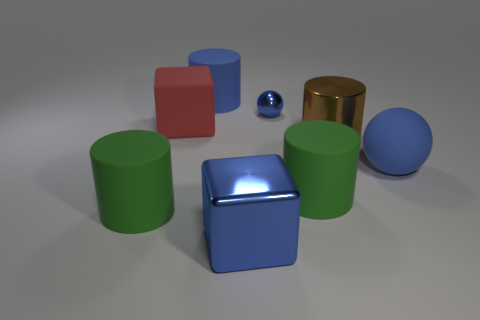Subtract all cyan cylinders. Subtract all green balls. How many cylinders are left? 4 Add 2 large cubes. How many objects exist? 10 Subtract all balls. How many objects are left? 6 Subtract all green cylinders. Subtract all small blue things. How many objects are left? 5 Add 6 big blue metal objects. How many big blue metal objects are left? 7 Add 5 large cubes. How many large cubes exist? 7 Subtract 0 red cylinders. How many objects are left? 8 